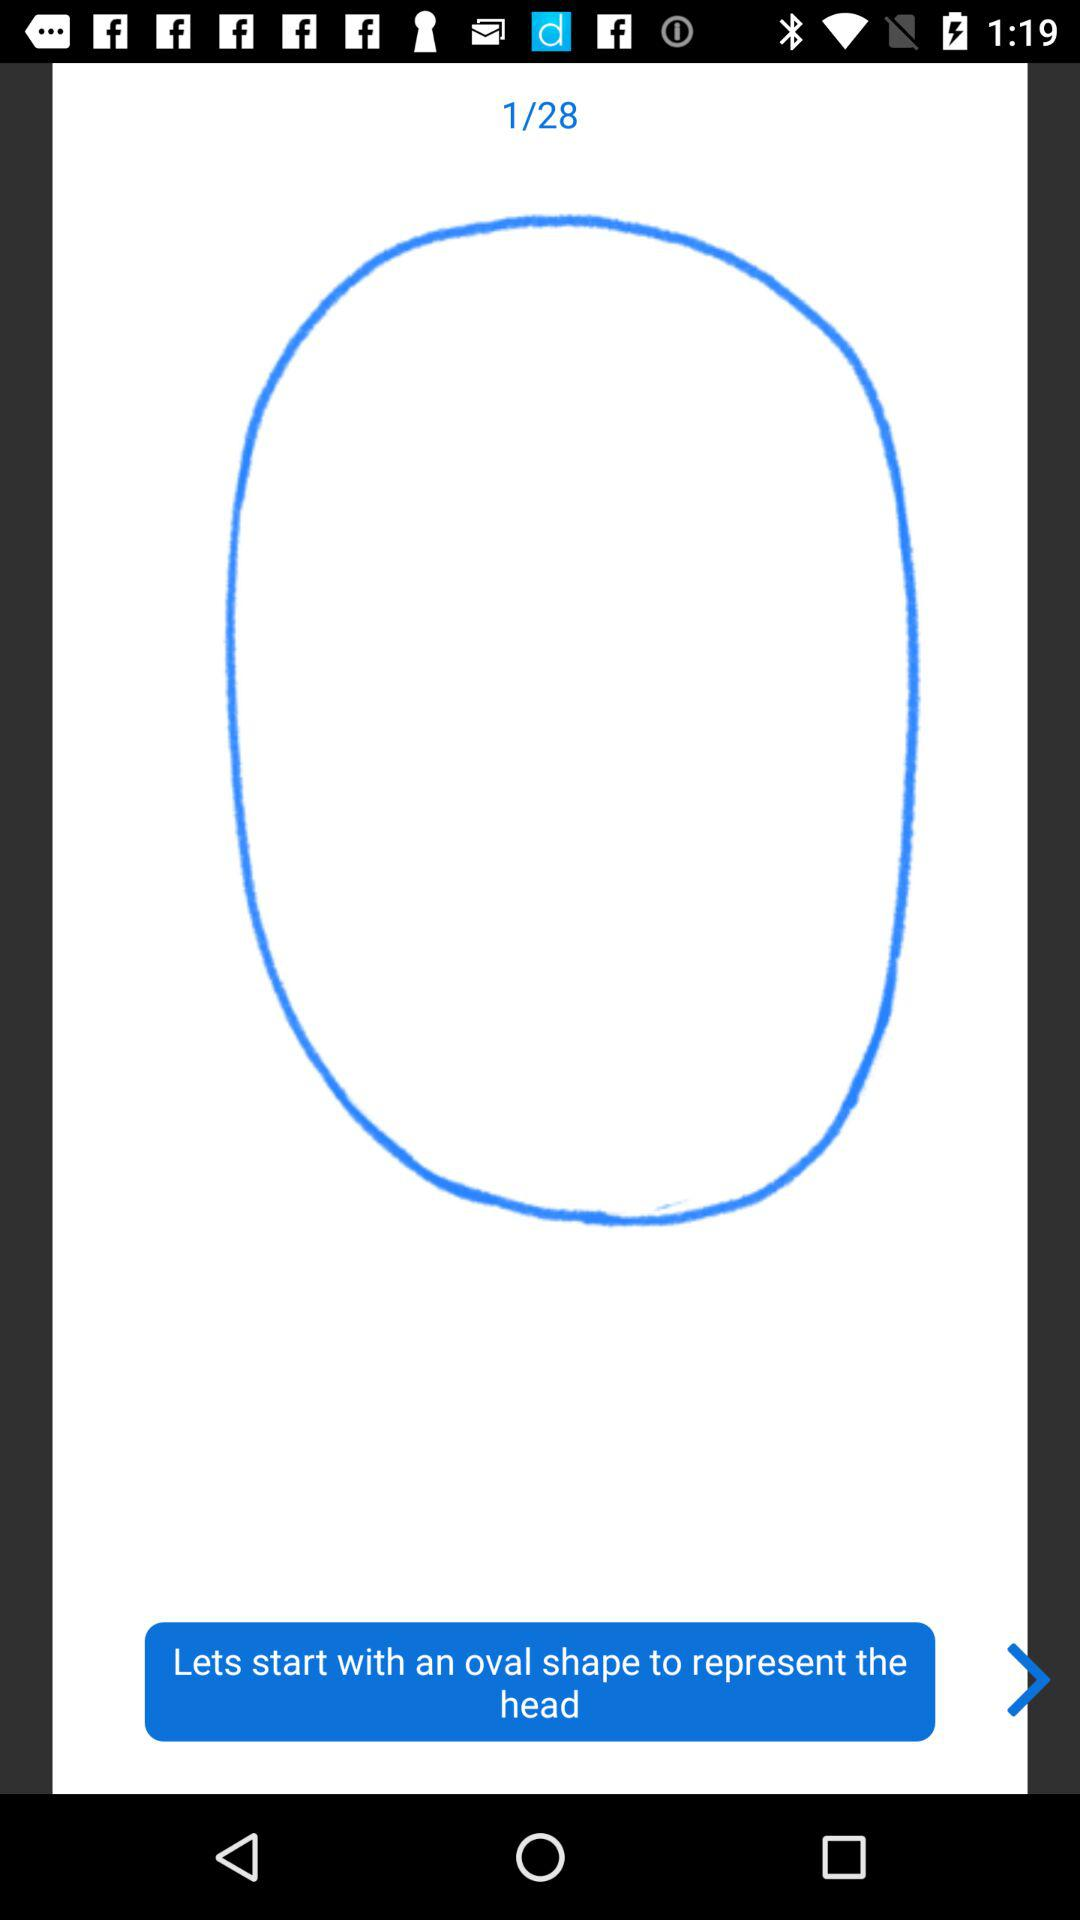Which page number am I on? You are on the first page. 